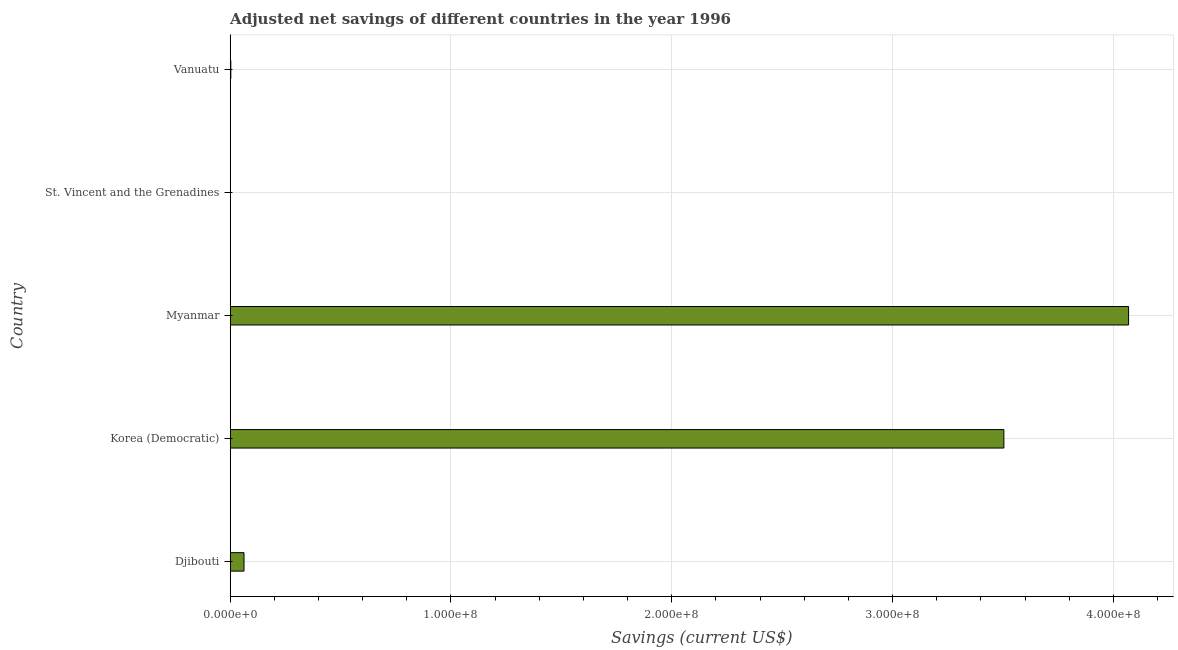Does the graph contain any zero values?
Ensure brevity in your answer.  No. What is the title of the graph?
Give a very brief answer. Adjusted net savings of different countries in the year 1996. What is the label or title of the X-axis?
Your response must be concise. Savings (current US$). What is the label or title of the Y-axis?
Your answer should be very brief. Country. What is the adjusted net savings in Djibouti?
Offer a very short reply. 6.26e+06. Across all countries, what is the maximum adjusted net savings?
Provide a short and direct response. 4.07e+08. Across all countries, what is the minimum adjusted net savings?
Offer a very short reply. 8.71e+04. In which country was the adjusted net savings maximum?
Ensure brevity in your answer.  Myanmar. In which country was the adjusted net savings minimum?
Offer a very short reply. St. Vincent and the Grenadines. What is the sum of the adjusted net savings?
Keep it short and to the point. 7.64e+08. What is the difference between the adjusted net savings in Myanmar and St. Vincent and the Grenadines?
Your answer should be compact. 4.07e+08. What is the average adjusted net savings per country?
Provide a succinct answer. 1.53e+08. What is the median adjusted net savings?
Provide a succinct answer. 6.26e+06. In how many countries, is the adjusted net savings greater than 240000000 US$?
Your answer should be very brief. 2. What is the ratio of the adjusted net savings in Djibouti to that in Myanmar?
Give a very brief answer. 0.01. Is the adjusted net savings in Korea (Democratic) less than that in St. Vincent and the Grenadines?
Keep it short and to the point. No. Is the difference between the adjusted net savings in St. Vincent and the Grenadines and Vanuatu greater than the difference between any two countries?
Keep it short and to the point. No. What is the difference between the highest and the second highest adjusted net savings?
Provide a succinct answer. 5.65e+07. What is the difference between the highest and the lowest adjusted net savings?
Ensure brevity in your answer.  4.07e+08. How many countries are there in the graph?
Provide a short and direct response. 5. What is the Savings (current US$) in Djibouti?
Provide a succinct answer. 6.26e+06. What is the Savings (current US$) in Korea (Democratic)?
Your response must be concise. 3.50e+08. What is the Savings (current US$) of Myanmar?
Your response must be concise. 4.07e+08. What is the Savings (current US$) in St. Vincent and the Grenadines?
Keep it short and to the point. 8.71e+04. What is the Savings (current US$) of Vanuatu?
Give a very brief answer. 2.88e+05. What is the difference between the Savings (current US$) in Djibouti and Korea (Democratic)?
Give a very brief answer. -3.44e+08. What is the difference between the Savings (current US$) in Djibouti and Myanmar?
Ensure brevity in your answer.  -4.01e+08. What is the difference between the Savings (current US$) in Djibouti and St. Vincent and the Grenadines?
Provide a succinct answer. 6.18e+06. What is the difference between the Savings (current US$) in Djibouti and Vanuatu?
Provide a short and direct response. 5.98e+06. What is the difference between the Savings (current US$) in Korea (Democratic) and Myanmar?
Your answer should be very brief. -5.65e+07. What is the difference between the Savings (current US$) in Korea (Democratic) and St. Vincent and the Grenadines?
Your answer should be compact. 3.50e+08. What is the difference between the Savings (current US$) in Korea (Democratic) and Vanuatu?
Keep it short and to the point. 3.50e+08. What is the difference between the Savings (current US$) in Myanmar and St. Vincent and the Grenadines?
Offer a terse response. 4.07e+08. What is the difference between the Savings (current US$) in Myanmar and Vanuatu?
Your response must be concise. 4.07e+08. What is the difference between the Savings (current US$) in St. Vincent and the Grenadines and Vanuatu?
Offer a terse response. -2.01e+05. What is the ratio of the Savings (current US$) in Djibouti to that in Korea (Democratic)?
Make the answer very short. 0.02. What is the ratio of the Savings (current US$) in Djibouti to that in Myanmar?
Ensure brevity in your answer.  0.01. What is the ratio of the Savings (current US$) in Djibouti to that in St. Vincent and the Grenadines?
Provide a succinct answer. 71.89. What is the ratio of the Savings (current US$) in Djibouti to that in Vanuatu?
Your response must be concise. 21.75. What is the ratio of the Savings (current US$) in Korea (Democratic) to that in Myanmar?
Give a very brief answer. 0.86. What is the ratio of the Savings (current US$) in Korea (Democratic) to that in St. Vincent and the Grenadines?
Provide a short and direct response. 4022.25. What is the ratio of the Savings (current US$) in Korea (Democratic) to that in Vanuatu?
Make the answer very short. 1217.09. What is the ratio of the Savings (current US$) in Myanmar to that in St. Vincent and the Grenadines?
Keep it short and to the point. 4670.49. What is the ratio of the Savings (current US$) in Myanmar to that in Vanuatu?
Your answer should be compact. 1413.24. What is the ratio of the Savings (current US$) in St. Vincent and the Grenadines to that in Vanuatu?
Ensure brevity in your answer.  0.3. 